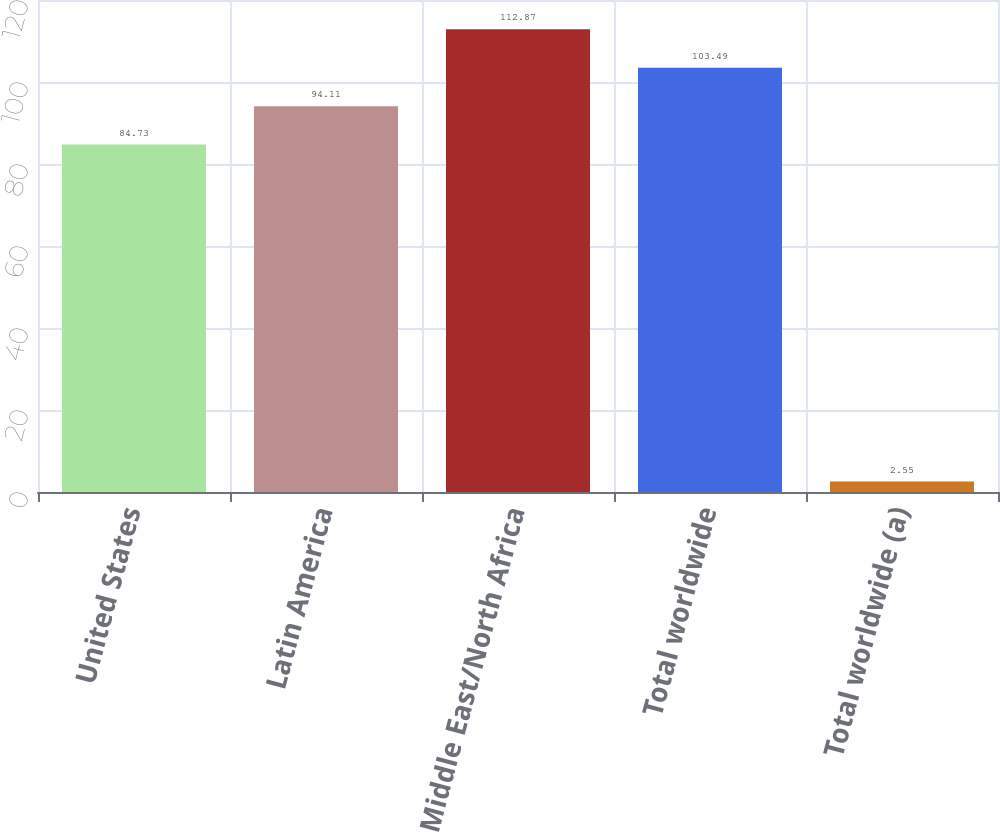<chart> <loc_0><loc_0><loc_500><loc_500><bar_chart><fcel>United States<fcel>Latin America<fcel>Middle East/North Africa<fcel>Total worldwide<fcel>Total worldwide (a)<nl><fcel>84.73<fcel>94.11<fcel>112.87<fcel>103.49<fcel>2.55<nl></chart> 